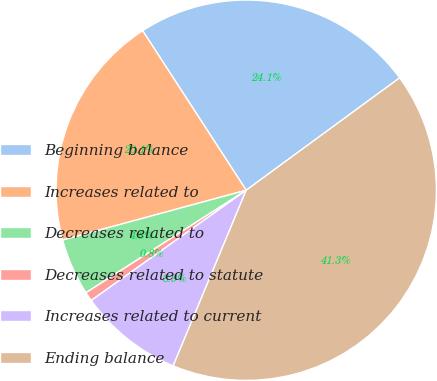Convert chart to OTSL. <chart><loc_0><loc_0><loc_500><loc_500><pie_chart><fcel>Beginning balance<fcel>Increases related to<fcel>Decreases related to<fcel>Decreases related to statute<fcel>Increases related to current<fcel>Ending balance<nl><fcel>24.1%<fcel>20.05%<fcel>4.84%<fcel>0.78%<fcel>8.89%<fcel>41.33%<nl></chart> 